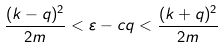<formula> <loc_0><loc_0><loc_500><loc_500>\frac { ( k - q ) ^ { 2 } } { 2 m } < \varepsilon - c q < \frac { ( k + q ) ^ { 2 } } { 2 m }</formula> 